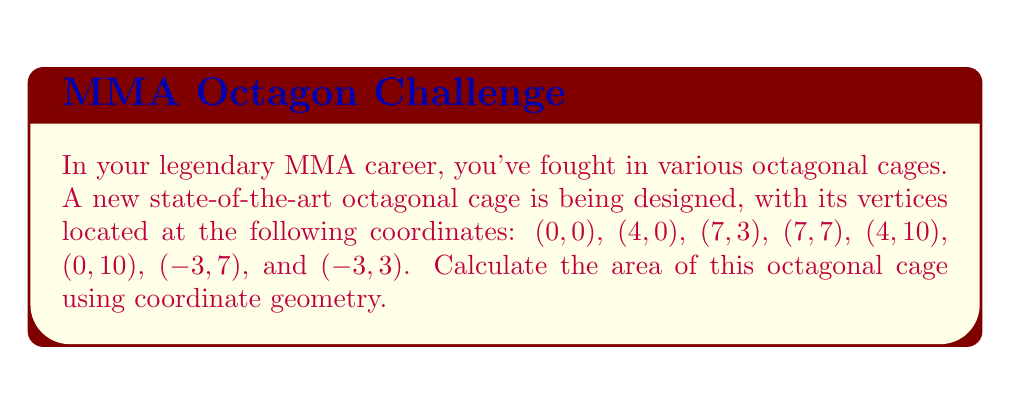Give your solution to this math problem. To find the area of the octagonal cage, we'll use the shoelace formula (also known as the surveyor's formula). This method calculates the area of a polygon given the coordinates of its vertices.

Step 1: Order the vertices
Let's number the vertices clockwise:
1. (0,0)
2. (4,0)
3. (7,3)
4. (7,7)
5. (4,10)
6. (0,10)
7. (-3,7)
8. (-3,3)

Step 2: Apply the shoelace formula
The formula is:

$$ A = \frac{1}{2}|\sum_{i=1}^{n-1} (x_iy_{i+1} - x_{i+1}y_i) + (x_ny_1 - x_1y_n)| $$

Where $(x_i, y_i)$ are the coordinates of the $i$-th vertex.

Step 3: Calculate each term
$$(0 \cdot 0) - (4 \cdot 0) = 0$$
$$(4 \cdot 3) - (7 \cdot 0) = 12$$
$$(7 \cdot 7) - (7 \cdot 3) = 28$$
$$(7 \cdot 10) - (4 \cdot 7) = 42$$
$$(4 \cdot 10) - (0 \cdot 10) = 40$$
$$(0 \cdot 7) - (-3 \cdot 10) = 30$$
$$(-3 \cdot 3) - (-3 \cdot 7) = 12$$
$$(-3 \cdot 0) - (0 \cdot 3) = 0$$

Step 4: Sum the terms
$$0 + 12 + 28 + 42 + 40 + 30 + 12 + 0 = 164$$

Step 5: Multiply by 1/2
$$\frac{1}{2} \cdot 164 = 82$$

Therefore, the area of the octagonal cage is 82 square units.
Answer: 82 square units 